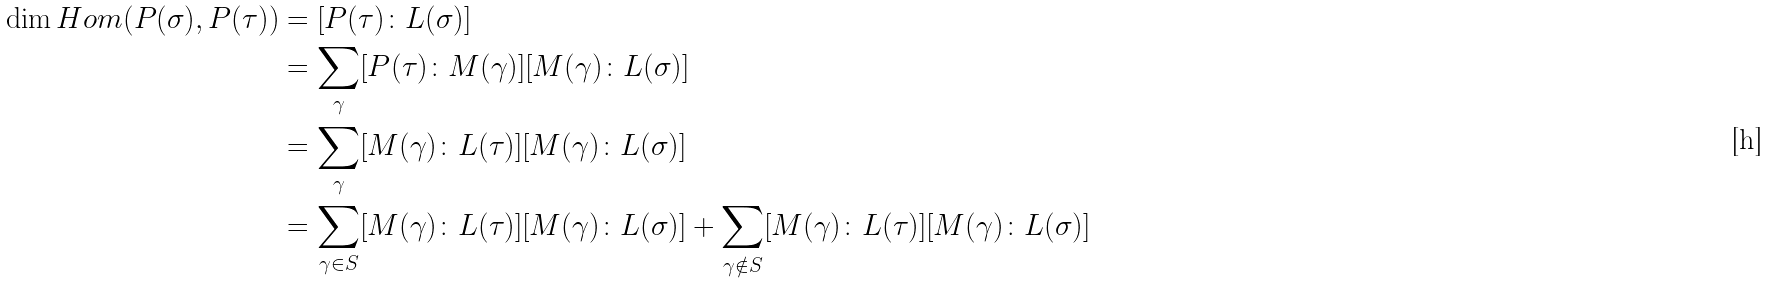Convert formula to latex. <formula><loc_0><loc_0><loc_500><loc_500>\dim H o m ( P ( \sigma ) , P ( \tau ) ) & = [ P ( \tau ) \colon L ( \sigma ) ] \\ & = \sum _ { \gamma } [ P ( \tau ) \colon M ( \gamma ) ] [ M ( \gamma ) \colon L ( \sigma ) ] \\ & = \sum _ { \gamma } [ M ( \gamma ) \colon L ( \tau ) ] [ M ( \gamma ) \colon L ( \sigma ) ] \\ & = \sum _ { \gamma \in S } [ M ( \gamma ) \colon L ( \tau ) ] [ M ( \gamma ) \colon L ( \sigma ) ] + \sum _ { \gamma \notin S } [ M ( \gamma ) \colon L ( \tau ) ] [ M ( \gamma ) \colon L ( \sigma ) ]</formula> 